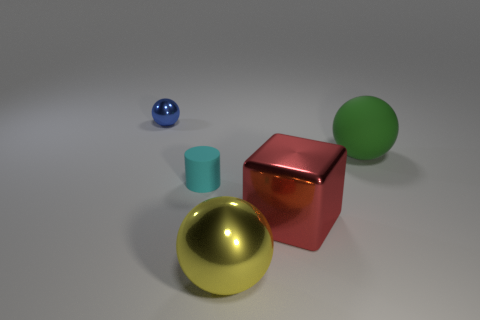Add 1 big green balls. How many objects exist? 6 Subtract all cylinders. How many objects are left? 4 Add 5 red metallic things. How many red metallic things are left? 6 Add 5 matte spheres. How many matte spheres exist? 6 Subtract 0 blue cylinders. How many objects are left? 5 Subtract all tiny gray things. Subtract all big green things. How many objects are left? 4 